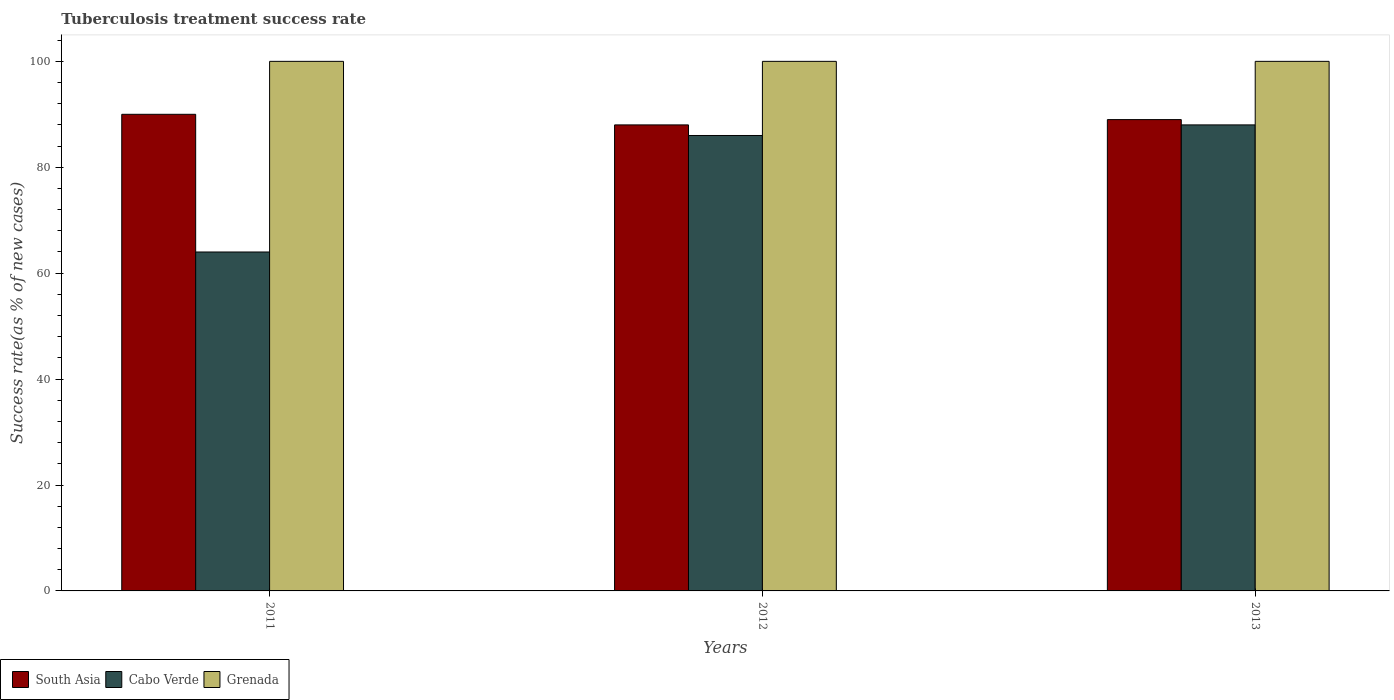Are the number of bars per tick equal to the number of legend labels?
Your answer should be very brief. Yes. How many bars are there on the 1st tick from the left?
Keep it short and to the point. 3. What is the tuberculosis treatment success rate in South Asia in 2012?
Give a very brief answer. 88. Across all years, what is the maximum tuberculosis treatment success rate in South Asia?
Provide a succinct answer. 90. In which year was the tuberculosis treatment success rate in South Asia maximum?
Offer a terse response. 2011. What is the total tuberculosis treatment success rate in South Asia in the graph?
Ensure brevity in your answer.  267. What is the difference between the tuberculosis treatment success rate in Cabo Verde in 2012 and that in 2013?
Offer a terse response. -2. What is the ratio of the tuberculosis treatment success rate in South Asia in 2011 to that in 2012?
Ensure brevity in your answer.  1.02. Is the tuberculosis treatment success rate in Cabo Verde in 2011 less than that in 2013?
Your response must be concise. Yes. What is the difference between the highest and the lowest tuberculosis treatment success rate in South Asia?
Your answer should be compact. 2. What does the 2nd bar from the left in 2013 represents?
Make the answer very short. Cabo Verde. What does the 1st bar from the right in 2013 represents?
Make the answer very short. Grenada. Is it the case that in every year, the sum of the tuberculosis treatment success rate in South Asia and tuberculosis treatment success rate in Cabo Verde is greater than the tuberculosis treatment success rate in Grenada?
Give a very brief answer. Yes. Are all the bars in the graph horizontal?
Your response must be concise. No. What is the difference between two consecutive major ticks on the Y-axis?
Provide a short and direct response. 20. Does the graph contain grids?
Offer a terse response. No. Where does the legend appear in the graph?
Keep it short and to the point. Bottom left. What is the title of the graph?
Your answer should be very brief. Tuberculosis treatment success rate. What is the label or title of the X-axis?
Keep it short and to the point. Years. What is the label or title of the Y-axis?
Your response must be concise. Success rate(as % of new cases). What is the Success rate(as % of new cases) in Grenada in 2011?
Offer a terse response. 100. What is the Success rate(as % of new cases) of South Asia in 2013?
Offer a terse response. 89. What is the Success rate(as % of new cases) in Cabo Verde in 2013?
Your answer should be compact. 88. What is the Success rate(as % of new cases) of Grenada in 2013?
Your response must be concise. 100. Across all years, what is the maximum Success rate(as % of new cases) in Cabo Verde?
Ensure brevity in your answer.  88. Across all years, what is the maximum Success rate(as % of new cases) of Grenada?
Keep it short and to the point. 100. Across all years, what is the minimum Success rate(as % of new cases) in Grenada?
Provide a succinct answer. 100. What is the total Success rate(as % of new cases) in South Asia in the graph?
Give a very brief answer. 267. What is the total Success rate(as % of new cases) in Cabo Verde in the graph?
Your answer should be very brief. 238. What is the total Success rate(as % of new cases) in Grenada in the graph?
Ensure brevity in your answer.  300. What is the difference between the Success rate(as % of new cases) in South Asia in 2011 and that in 2012?
Your answer should be very brief. 2. What is the difference between the Success rate(as % of new cases) of Cabo Verde in 2011 and that in 2012?
Provide a succinct answer. -22. What is the difference between the Success rate(as % of new cases) of Grenada in 2011 and that in 2012?
Offer a terse response. 0. What is the difference between the Success rate(as % of new cases) in Cabo Verde in 2011 and that in 2013?
Ensure brevity in your answer.  -24. What is the difference between the Success rate(as % of new cases) of Grenada in 2011 and that in 2013?
Offer a terse response. 0. What is the difference between the Success rate(as % of new cases) in South Asia in 2011 and the Success rate(as % of new cases) in Cabo Verde in 2012?
Your answer should be compact. 4. What is the difference between the Success rate(as % of new cases) in Cabo Verde in 2011 and the Success rate(as % of new cases) in Grenada in 2012?
Give a very brief answer. -36. What is the difference between the Success rate(as % of new cases) in Cabo Verde in 2011 and the Success rate(as % of new cases) in Grenada in 2013?
Keep it short and to the point. -36. What is the difference between the Success rate(as % of new cases) of South Asia in 2012 and the Success rate(as % of new cases) of Cabo Verde in 2013?
Provide a short and direct response. 0. What is the average Success rate(as % of new cases) of South Asia per year?
Give a very brief answer. 89. What is the average Success rate(as % of new cases) of Cabo Verde per year?
Provide a succinct answer. 79.33. What is the average Success rate(as % of new cases) in Grenada per year?
Your answer should be very brief. 100. In the year 2011, what is the difference between the Success rate(as % of new cases) of South Asia and Success rate(as % of new cases) of Cabo Verde?
Your answer should be very brief. 26. In the year 2011, what is the difference between the Success rate(as % of new cases) of South Asia and Success rate(as % of new cases) of Grenada?
Provide a succinct answer. -10. In the year 2011, what is the difference between the Success rate(as % of new cases) of Cabo Verde and Success rate(as % of new cases) of Grenada?
Your response must be concise. -36. In the year 2012, what is the difference between the Success rate(as % of new cases) of Cabo Verde and Success rate(as % of new cases) of Grenada?
Give a very brief answer. -14. In the year 2013, what is the difference between the Success rate(as % of new cases) of South Asia and Success rate(as % of new cases) of Grenada?
Provide a succinct answer. -11. In the year 2013, what is the difference between the Success rate(as % of new cases) in Cabo Verde and Success rate(as % of new cases) in Grenada?
Keep it short and to the point. -12. What is the ratio of the Success rate(as % of new cases) in South Asia in 2011 to that in 2012?
Your response must be concise. 1.02. What is the ratio of the Success rate(as % of new cases) of Cabo Verde in 2011 to that in 2012?
Your answer should be compact. 0.74. What is the ratio of the Success rate(as % of new cases) in Grenada in 2011 to that in 2012?
Provide a short and direct response. 1. What is the ratio of the Success rate(as % of new cases) in South Asia in 2011 to that in 2013?
Provide a succinct answer. 1.01. What is the ratio of the Success rate(as % of new cases) in Cabo Verde in 2011 to that in 2013?
Provide a succinct answer. 0.73. What is the ratio of the Success rate(as % of new cases) of Grenada in 2011 to that in 2013?
Ensure brevity in your answer.  1. What is the ratio of the Success rate(as % of new cases) of Cabo Verde in 2012 to that in 2013?
Keep it short and to the point. 0.98. What is the difference between the highest and the second highest Success rate(as % of new cases) in Grenada?
Provide a short and direct response. 0. What is the difference between the highest and the lowest Success rate(as % of new cases) in South Asia?
Offer a very short reply. 2. What is the difference between the highest and the lowest Success rate(as % of new cases) of Cabo Verde?
Your response must be concise. 24. What is the difference between the highest and the lowest Success rate(as % of new cases) of Grenada?
Provide a short and direct response. 0. 